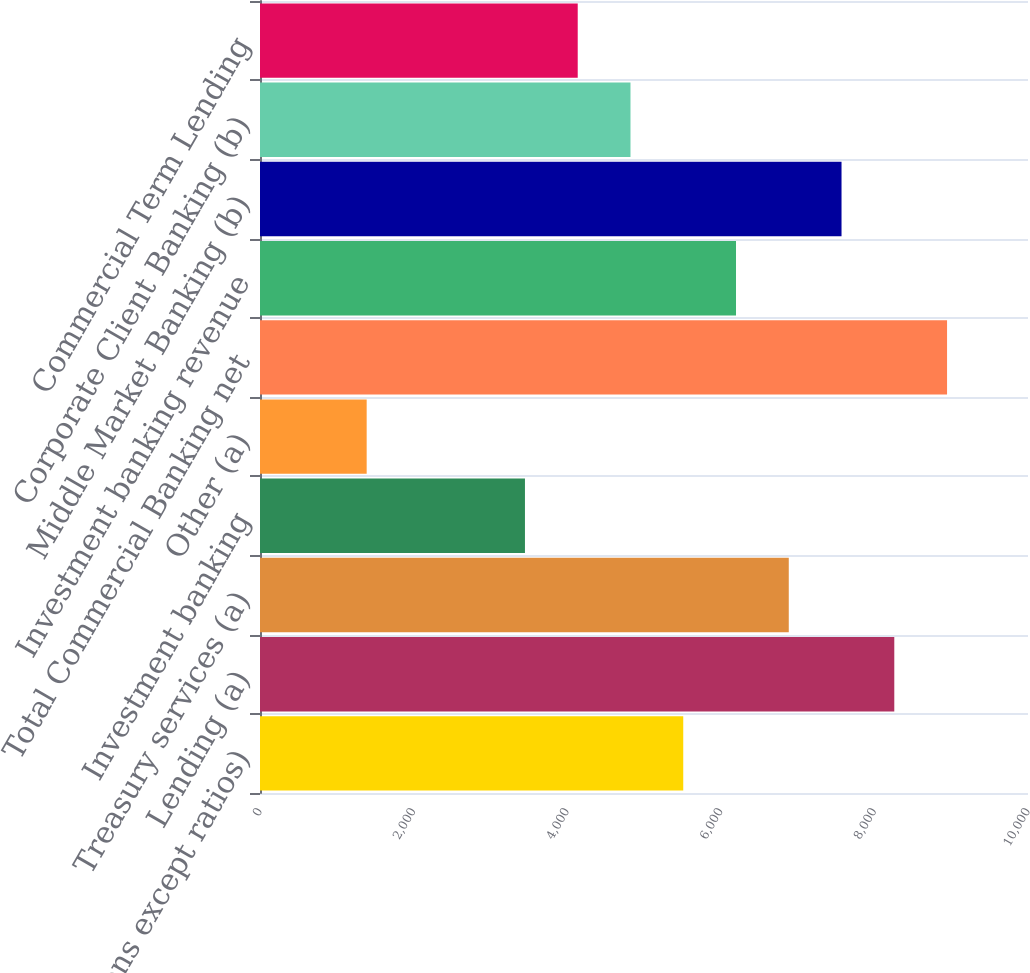<chart> <loc_0><loc_0><loc_500><loc_500><bar_chart><fcel>(in millions except ratios)<fcel>Lending (a)<fcel>Treasury services (a)<fcel>Investment banking<fcel>Other (a)<fcel>Total Commercial Banking net<fcel>Investment banking revenue<fcel>Middle Market Banking (b)<fcel>Corporate Client Banking (b)<fcel>Commercial Term Lending<nl><fcel>5511<fcel>8259<fcel>6885<fcel>3450<fcel>1389<fcel>8946<fcel>6198<fcel>7572<fcel>4824<fcel>4137<nl></chart> 